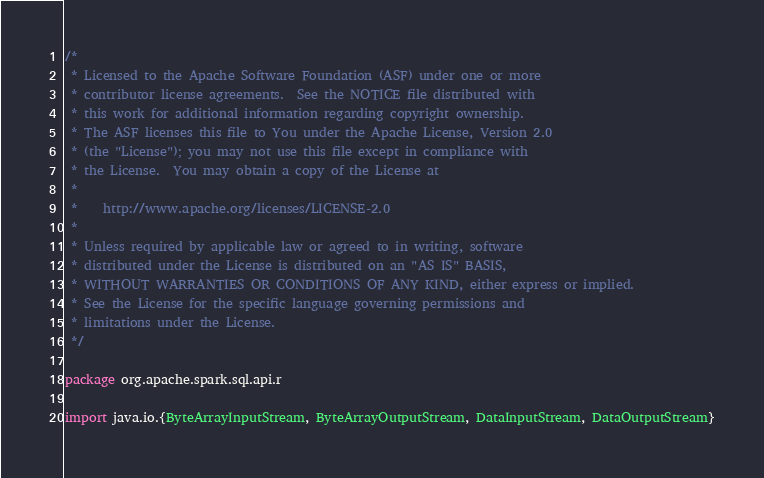<code> <loc_0><loc_0><loc_500><loc_500><_Scala_>/*
 * Licensed to the Apache Software Foundation (ASF) under one or more
 * contributor license agreements.  See the NOTICE file distributed with
 * this work for additional information regarding copyright ownership.
 * The ASF licenses this file to You under the Apache License, Version 2.0
 * (the "License"); you may not use this file except in compliance with
 * the License.  You may obtain a copy of the License at
 *
 *    http://www.apache.org/licenses/LICENSE-2.0
 *
 * Unless required by applicable law or agreed to in writing, software
 * distributed under the License is distributed on an "AS IS" BASIS,
 * WITHOUT WARRANTIES OR CONDITIONS OF ANY KIND, either express or implied.
 * See the License for the specific language governing permissions and
 * limitations under the License.
 */

package org.apache.spark.sql.api.r

import java.io.{ByteArrayInputStream, ByteArrayOutputStream, DataInputStream, DataOutputStream}</code> 